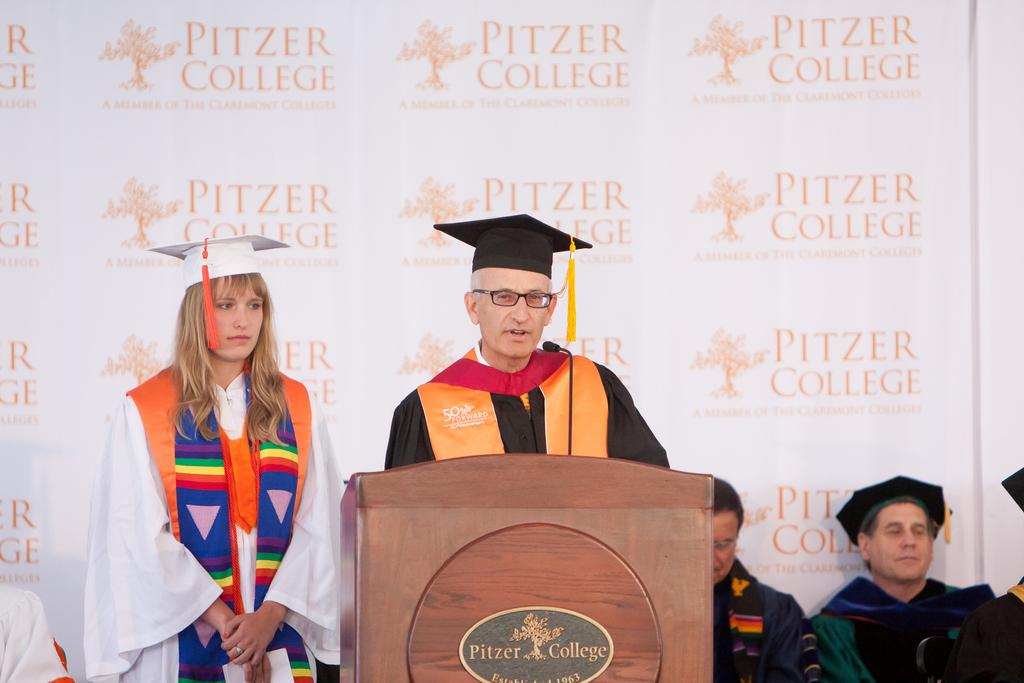What is the main activity of the people in the image? The people in the image are standing and sitting. What object can be seen in the image that is typically used for presentations? There is a podium in the image. What is written on the podium? The podium has text on it. What type of seating arrangement is visible in the image? There are people sitting in the image. What can be seen in the background of the image? There is a banner in the background of the image. What is written on the banner? The banner has text on it. What type of wool is being used to create a nest in the image? There is no wool or nest present in the image. 